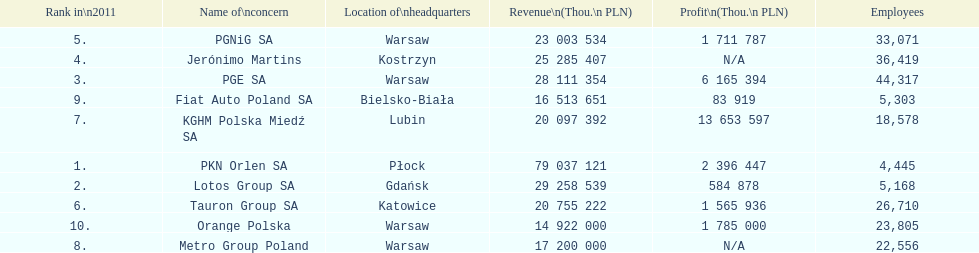Which company had the least revenue? Orange Polska. 